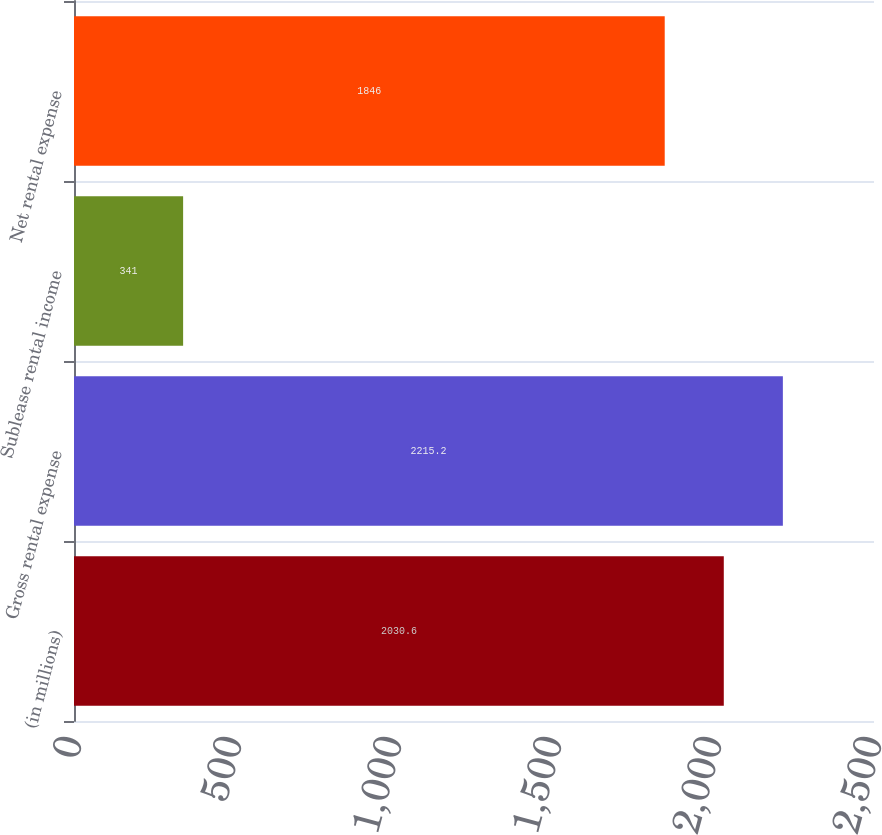Convert chart to OTSL. <chart><loc_0><loc_0><loc_500><loc_500><bar_chart><fcel>(in millions)<fcel>Gross rental expense<fcel>Sublease rental income<fcel>Net rental expense<nl><fcel>2030.6<fcel>2215.2<fcel>341<fcel>1846<nl></chart> 